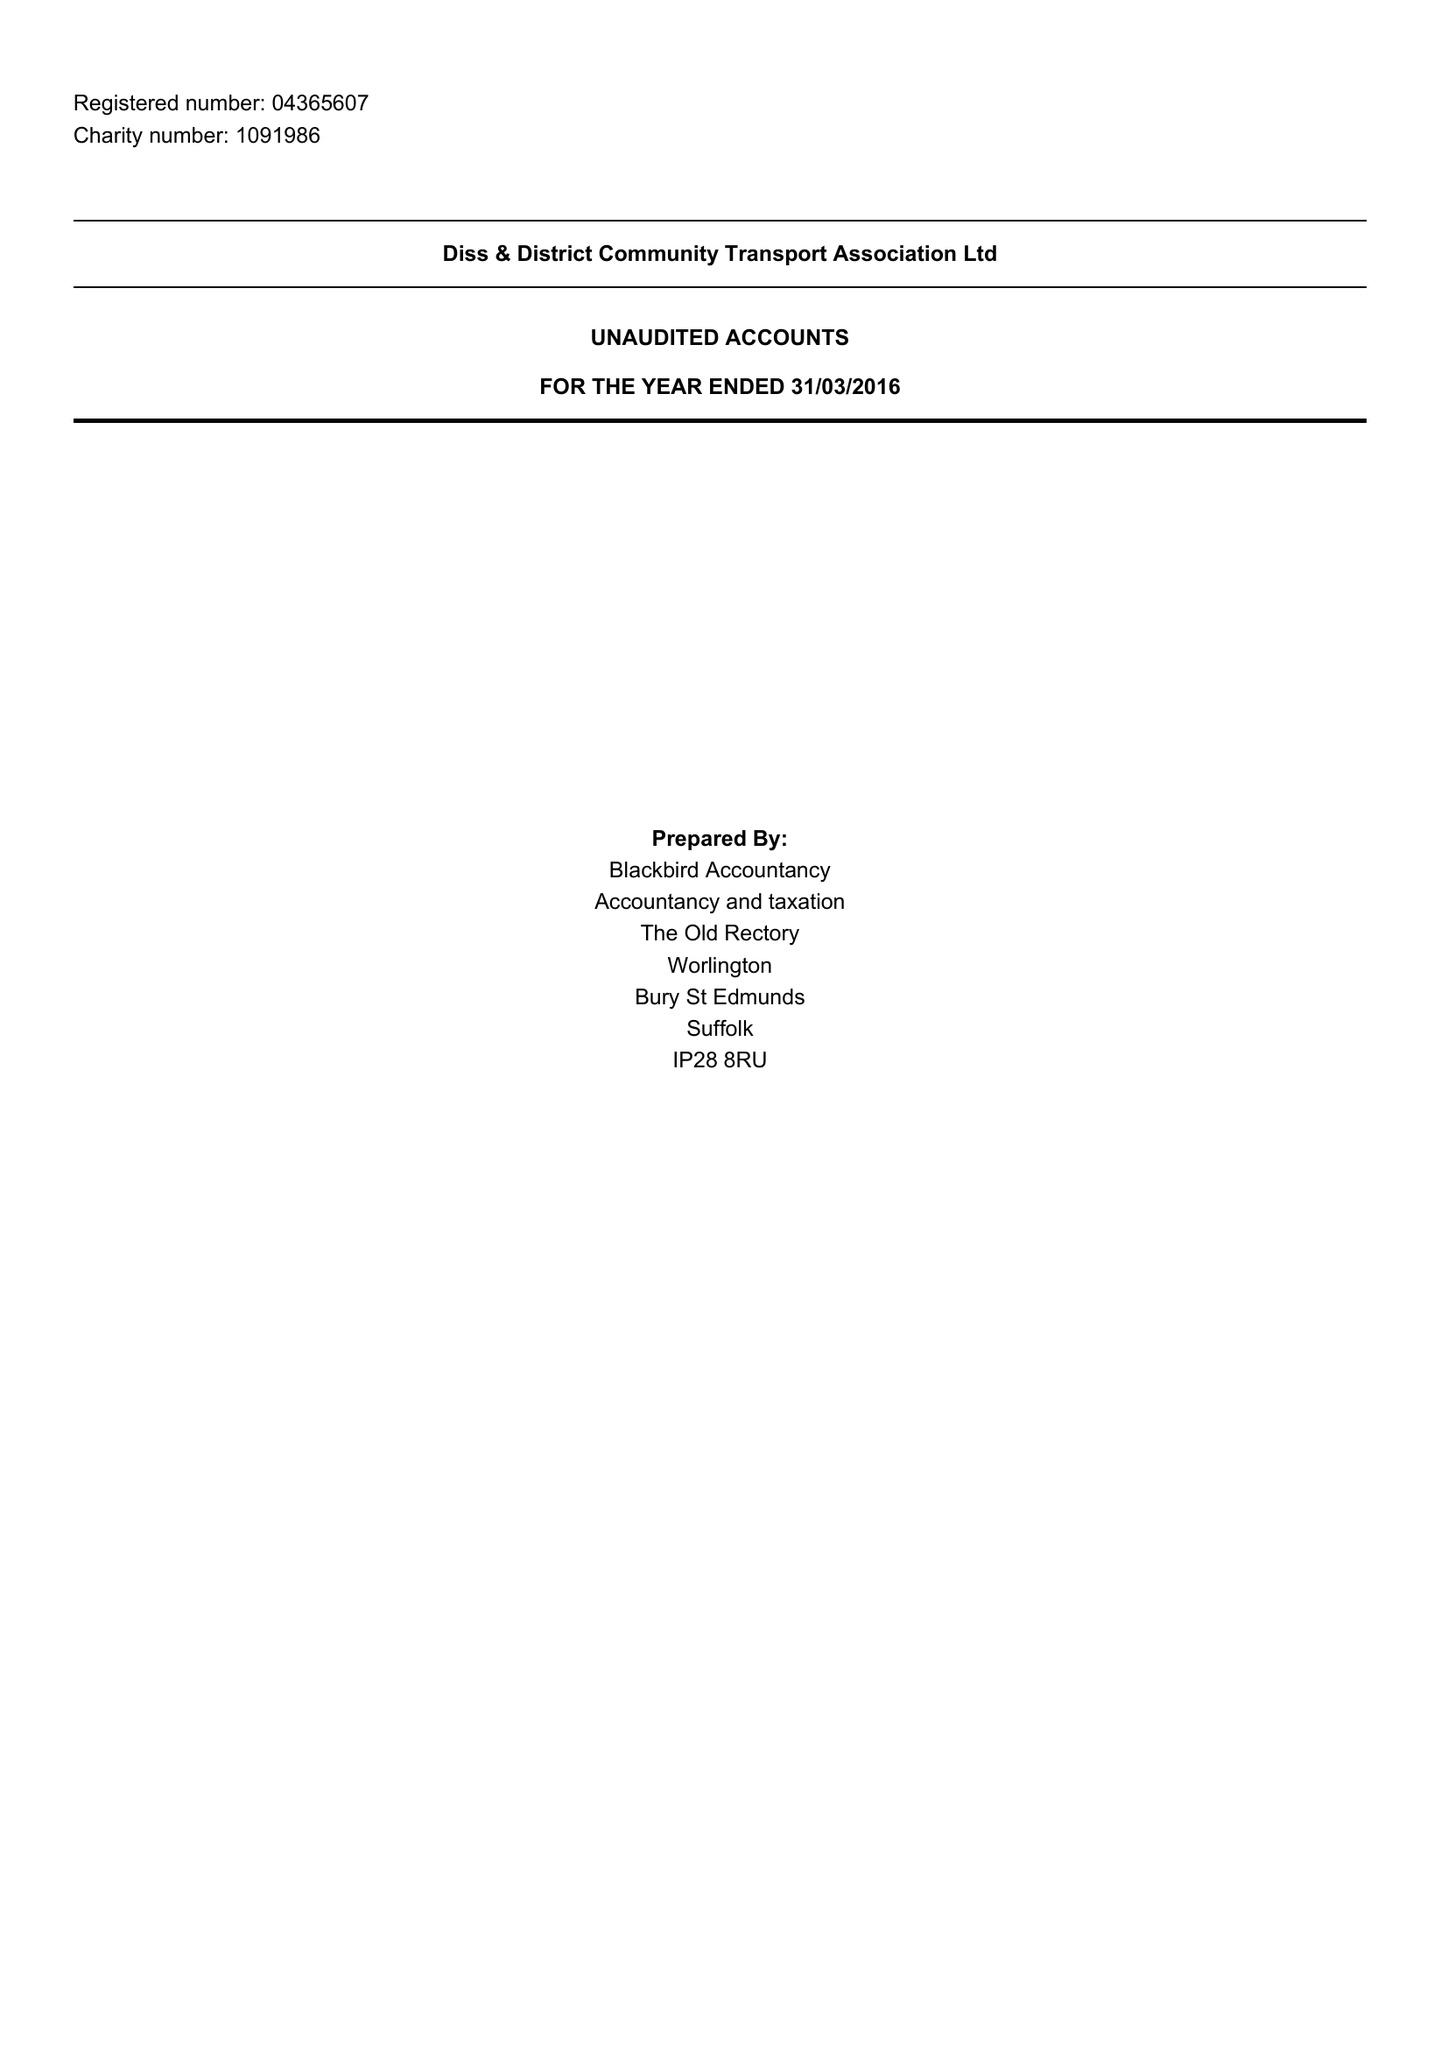What is the value for the income_annually_in_british_pounds?
Answer the question using a single word or phrase. 270507.00 